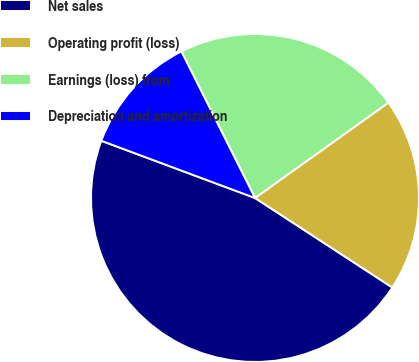Convert chart to OTSL. <chart><loc_0><loc_0><loc_500><loc_500><pie_chart><fcel>Net sales<fcel>Operating profit (loss)<fcel>Earnings (loss) from<fcel>Depreciation and amortization<nl><fcel>46.48%<fcel>19.07%<fcel>22.53%<fcel>11.92%<nl></chart> 